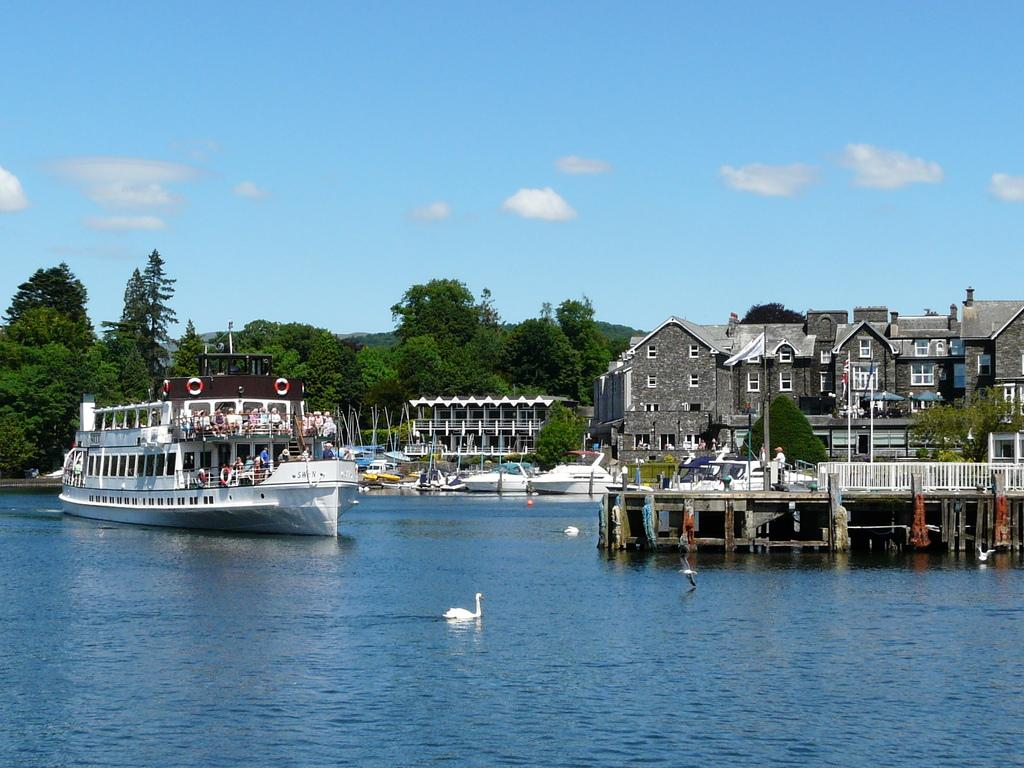What can be seen in the sky in the image? The sky with clouds is visible in the image. What type of vegetation is present in the image? There are trees in the image. What geographical feature is visible in the image? Hills are present in the image. What type of vehicles can be seen in the image? Ships are visible in the image. What type of structure is in the image? An iron grill is in the image. What type of man-made structures are present in the image? Buildings are present in the image. What symbol is visible in the image? There is a flag in the image. What is the flag attached to in the image? A flag post is in the image. What animals are on the water in the image? Swans are on the water in the image. What body of water is visible in the image? A lake is visible in the image. What type of credit card is being used to purchase the swans in the image? There is no credit card or purchase of swans depicted in the image. What is causing the throat irritation in the image? There is no indication of throat irritation or any related issue in the image. 